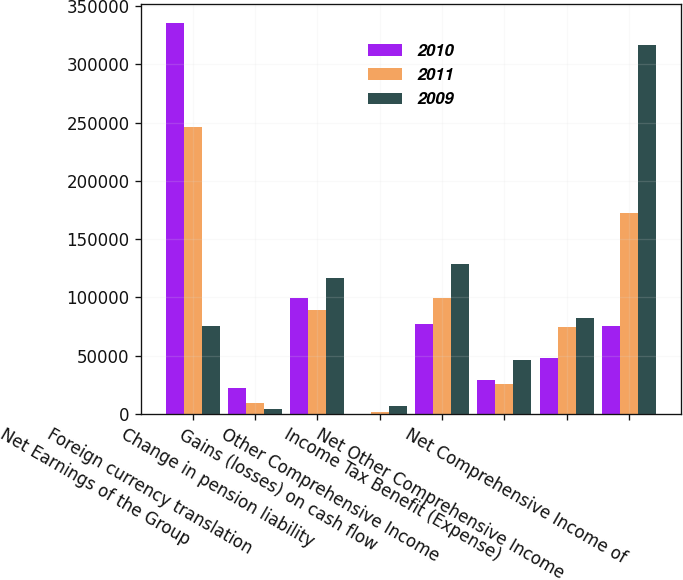<chart> <loc_0><loc_0><loc_500><loc_500><stacked_bar_chart><ecel><fcel>Net Earnings of the Group<fcel>Foreign currency translation<fcel>Change in pension liability<fcel>Gains (losses) on cash flow<fcel>Other Comprehensive Income<fcel>Income Tax Benefit (Expense)<fcel>Net Other Comprehensive Income<fcel>Net Comprehensive Income of<nl><fcel>2010<fcel>335221<fcel>22524<fcel>99881<fcel>137<fcel>77494<fcel>29291<fcel>48203<fcel>75860<nl><fcel>2011<fcel>246287<fcel>9338<fcel>89091<fcel>1444<fcel>99873<fcel>25647<fcel>74226<fcel>172061<nl><fcel>2009<fcel>75860<fcel>4106<fcel>116381<fcel>6623<fcel>128505<fcel>46260<fcel>82245<fcel>316968<nl></chart> 